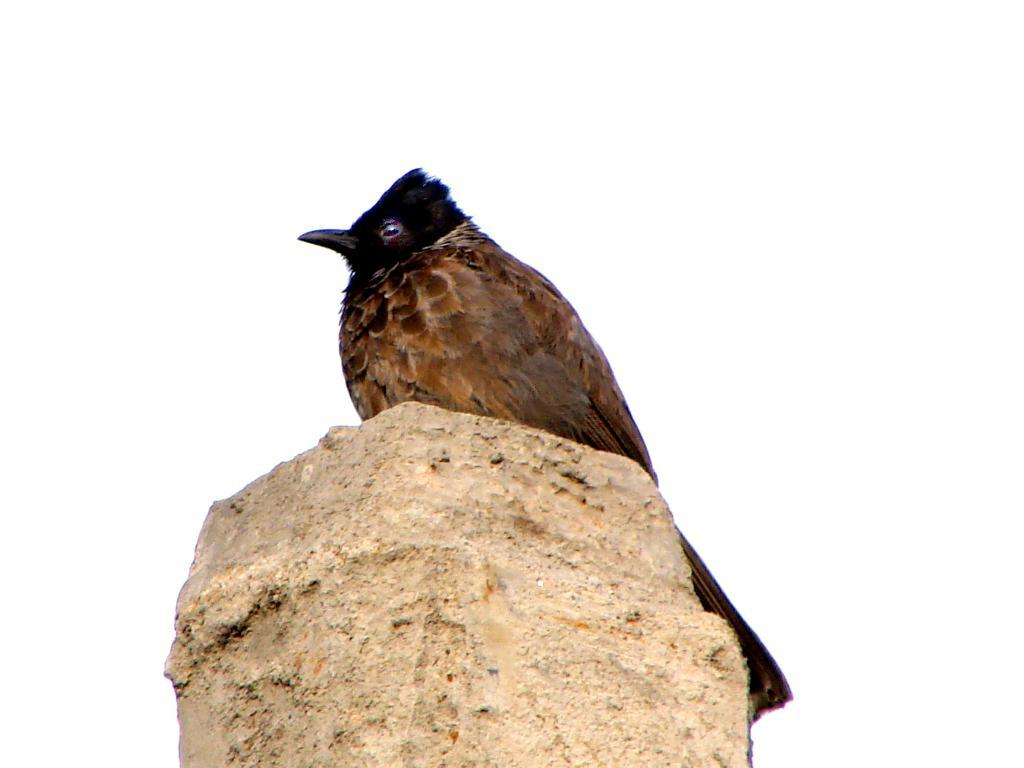What type of animal can be seen in the image? There is a bird in the image. Where is the bird located? The bird is on a pillar or cement block. What colors are present on the bird? The bird has black and brown coloring. What is the bird's beak like? The bird has a long black beak. What color is the background of the image? The background of the image is white in color. What type of bread is the bird eating in the image? There is no bread present in the image; the bird is simply perched on a pillar or cement block. 